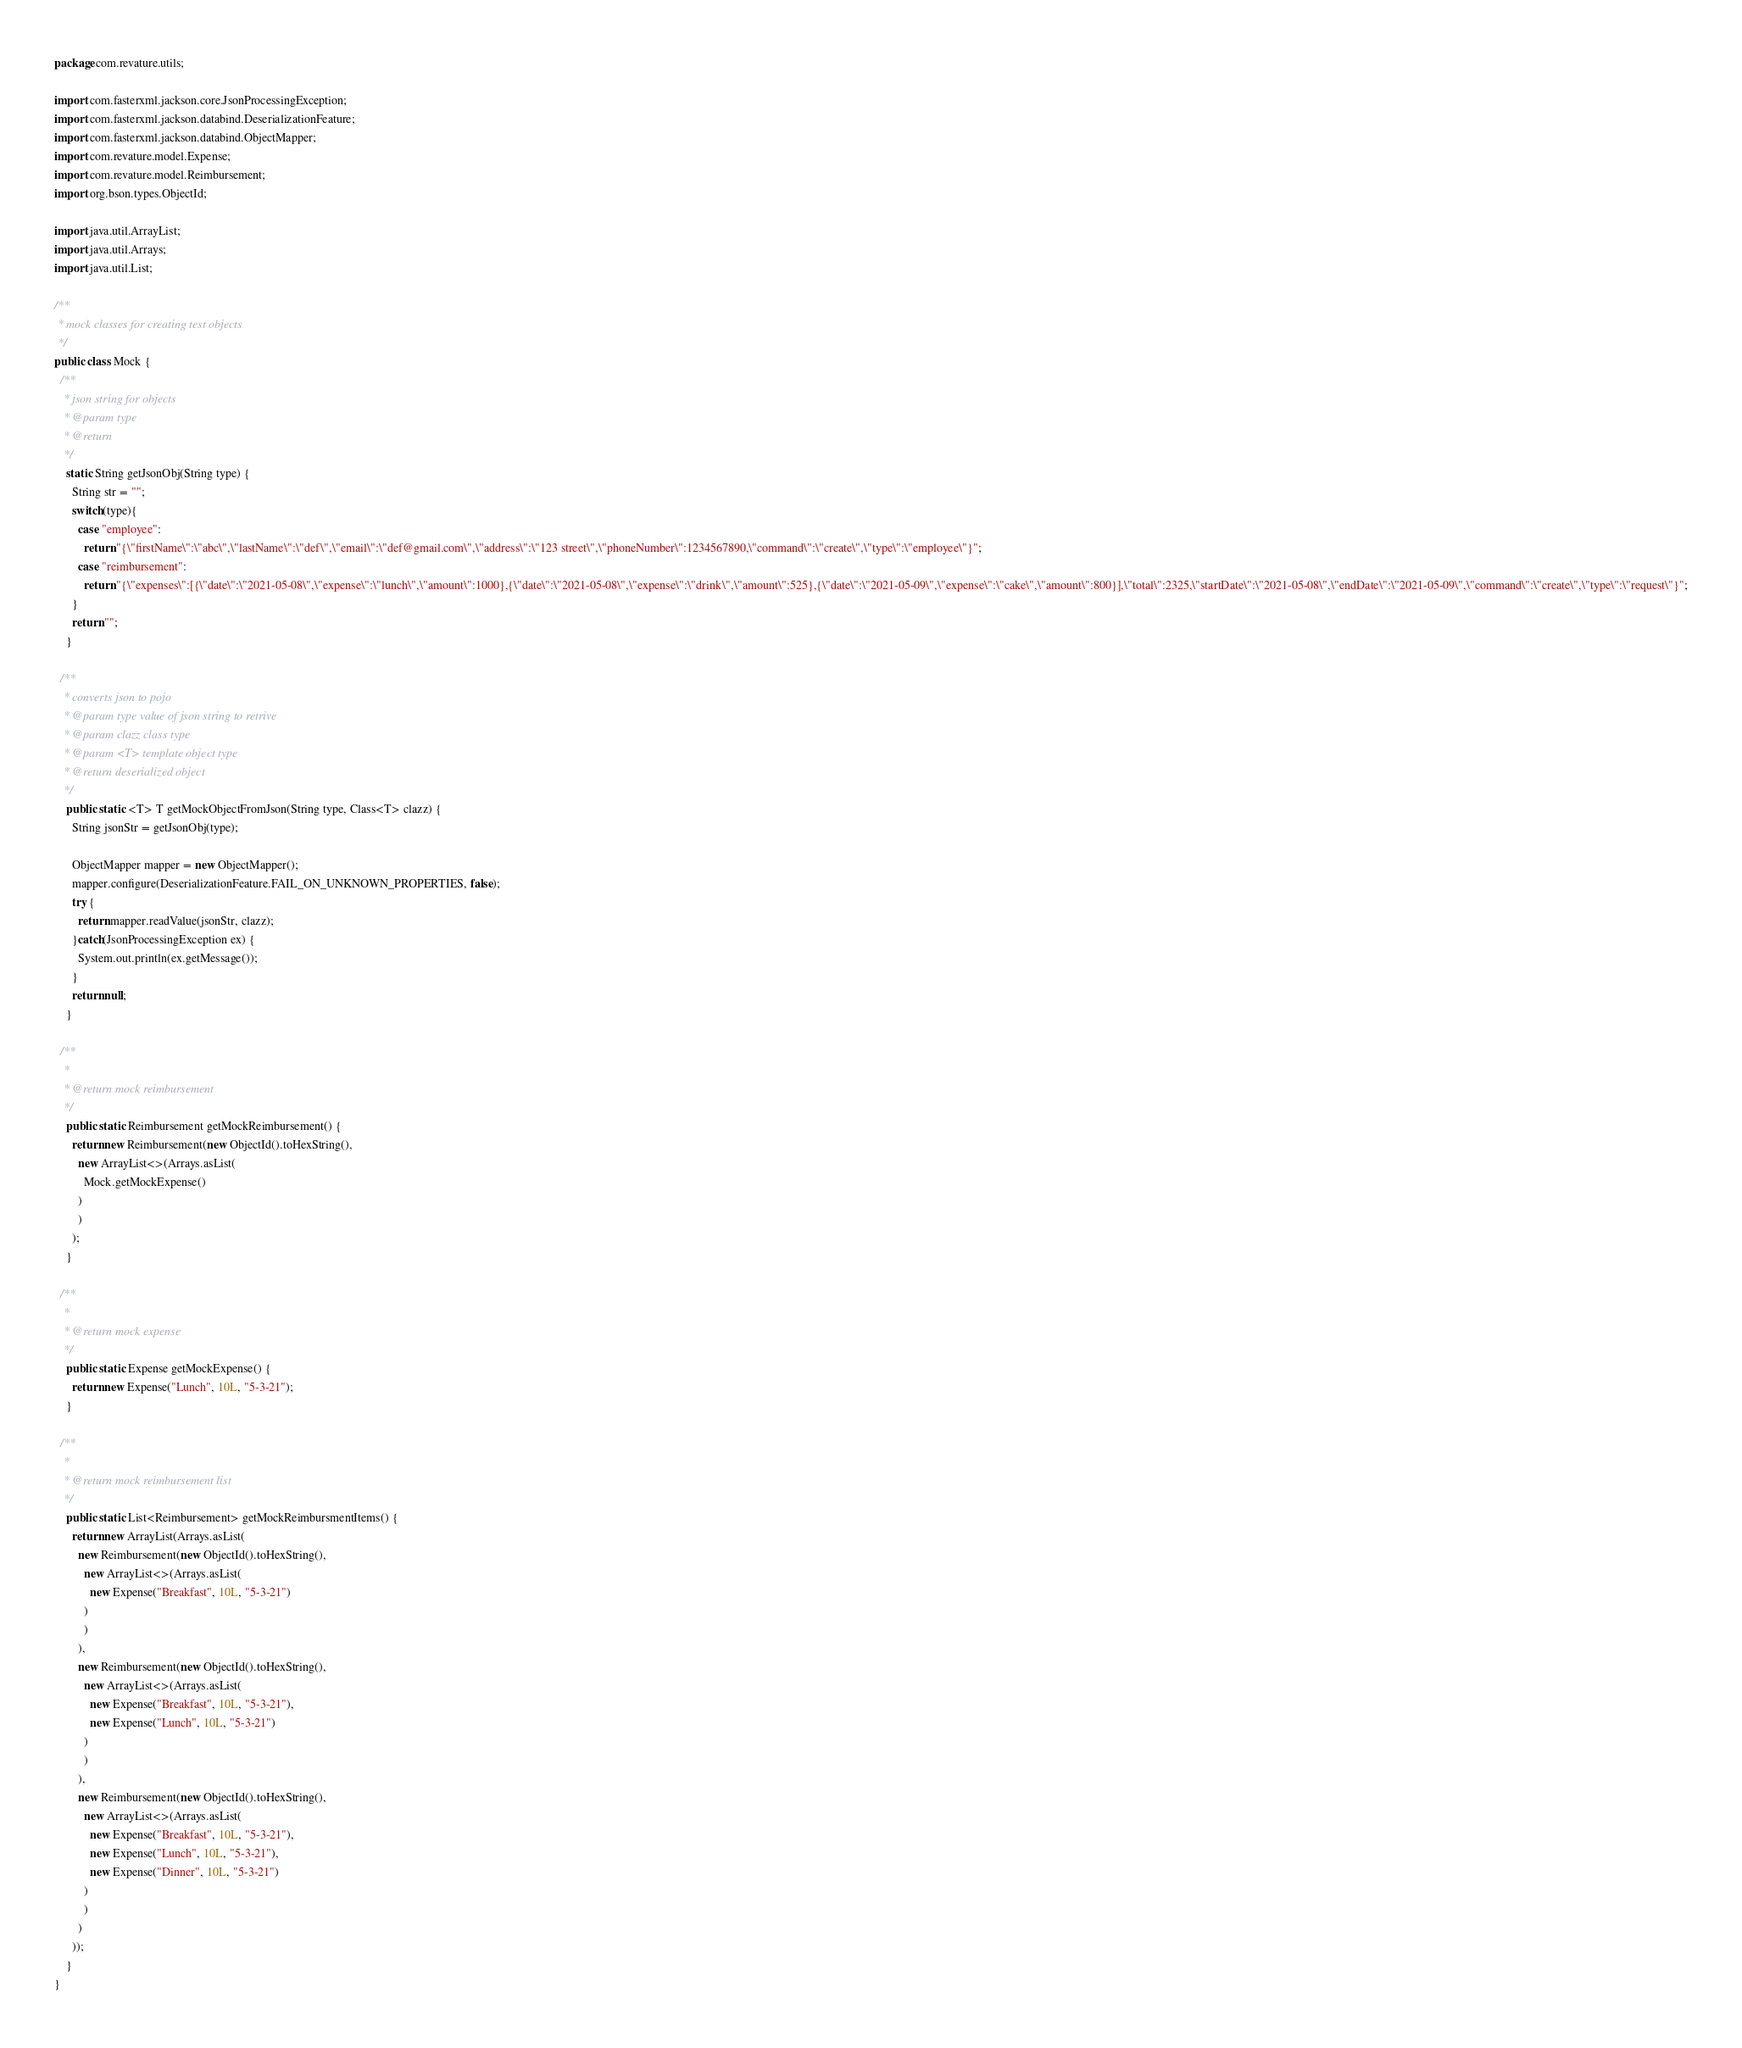<code> <loc_0><loc_0><loc_500><loc_500><_Java_>package com.revature.utils;

import com.fasterxml.jackson.core.JsonProcessingException;
import com.fasterxml.jackson.databind.DeserializationFeature;
import com.fasterxml.jackson.databind.ObjectMapper;
import com.revature.model.Expense;
import com.revature.model.Reimbursement;
import org.bson.types.ObjectId;

import java.util.ArrayList;
import java.util.Arrays;
import java.util.List;

/**
 * mock classes for creating test objects
 */
public class Mock {
  /**
   * json string for objects
   * @param type
   * @return
   */
    static String getJsonObj(String type) {
      String str = "";
      switch(type){
        case "employee":
          return "{\"firstName\":\"abc\",\"lastName\":\"def\",\"email\":\"def@gmail.com\",\"address\":\"123 street\",\"phoneNumber\":1234567890,\"command\":\"create\",\"type\":\"employee\"}";
        case "reimbursement":
          return "{\"expenses\":[{\"date\":\"2021-05-08\",\"expense\":\"lunch\",\"amount\":1000},{\"date\":\"2021-05-08\",\"expense\":\"drink\",\"amount\":525},{\"date\":\"2021-05-09\",\"expense\":\"cake\",\"amount\":800}],\"total\":2325,\"startDate\":\"2021-05-08\",\"endDate\":\"2021-05-09\",\"command\":\"create\",\"type\":\"request\"}";
      }
      return "";
    }

  /**
   * converts json to pojo
   * @param type value of json string to retrive
   * @param clazz class type
   * @param <T> template object type
   * @return deserialized object
   */
    public static <T> T getMockObjectFromJson(String type, Class<T> clazz) {
      String jsonStr = getJsonObj(type);

      ObjectMapper mapper = new ObjectMapper();
      mapper.configure(DeserializationFeature.FAIL_ON_UNKNOWN_PROPERTIES, false);
      try {
        return mapper.readValue(jsonStr, clazz);
      }catch(JsonProcessingException ex) {
        System.out.println(ex.getMessage());
      }
      return null;
    }

  /**
   *
   * @return mock reimbursement
   */
    public static Reimbursement getMockReimbursement() {
      return new Reimbursement(new ObjectId().toHexString(),
        new ArrayList<>(Arrays.asList(
          Mock.getMockExpense()
        )
        )
      );
    }

  /**
   *
   * @return mock expense
   */
    public static Expense getMockExpense() {
      return new Expense("Lunch", 10L, "5-3-21");
    }

  /**
   *
   * @return mock reimbursement list
   */
    public static List<Reimbursement> getMockReimbursmentItems() {
      return new ArrayList(Arrays.asList(
        new Reimbursement(new ObjectId().toHexString(),
          new ArrayList<>(Arrays.asList(
            new Expense("Breakfast", 10L, "5-3-21")
          )
          )
        ),
        new Reimbursement(new ObjectId().toHexString(),
          new ArrayList<>(Arrays.asList(
            new Expense("Breakfast", 10L, "5-3-21"),
            new Expense("Lunch", 10L, "5-3-21")
          )
          )
        ),
        new Reimbursement(new ObjectId().toHexString(),
          new ArrayList<>(Arrays.asList(
            new Expense("Breakfast", 10L, "5-3-21"),
            new Expense("Lunch", 10L, "5-3-21"),
            new Expense("Dinner", 10L, "5-3-21")
          )
          )
        )
      ));
    }
}
</code> 